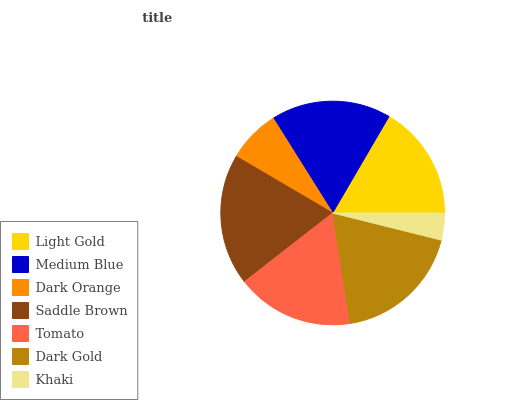Is Khaki the minimum?
Answer yes or no. Yes. Is Saddle Brown the maximum?
Answer yes or no. Yes. Is Medium Blue the minimum?
Answer yes or no. No. Is Medium Blue the maximum?
Answer yes or no. No. Is Medium Blue greater than Light Gold?
Answer yes or no. Yes. Is Light Gold less than Medium Blue?
Answer yes or no. Yes. Is Light Gold greater than Medium Blue?
Answer yes or no. No. Is Medium Blue less than Light Gold?
Answer yes or no. No. Is Tomato the high median?
Answer yes or no. Yes. Is Tomato the low median?
Answer yes or no. Yes. Is Light Gold the high median?
Answer yes or no. No. Is Dark Gold the low median?
Answer yes or no. No. 